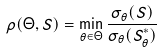<formula> <loc_0><loc_0><loc_500><loc_500>\rho ( \Theta , S ) = \min _ { \theta \in \Theta } \frac { \sigma _ { \theta } ( S ) } { \sigma _ { \theta } ( S ^ { * } _ { \theta } ) }</formula> 